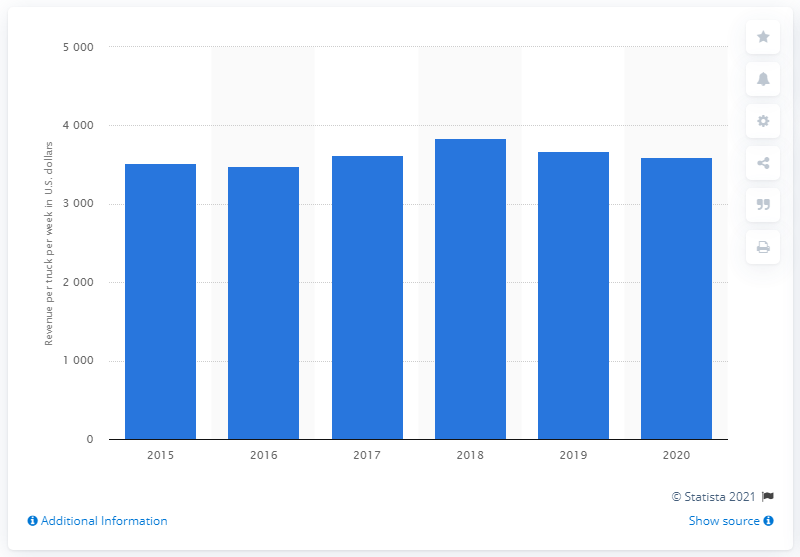Specify some key components in this picture. Schneider National's truckload segment was last in business in 2015. In the year 2020, Schneider National's truckload segment concluded its fiscal year. 